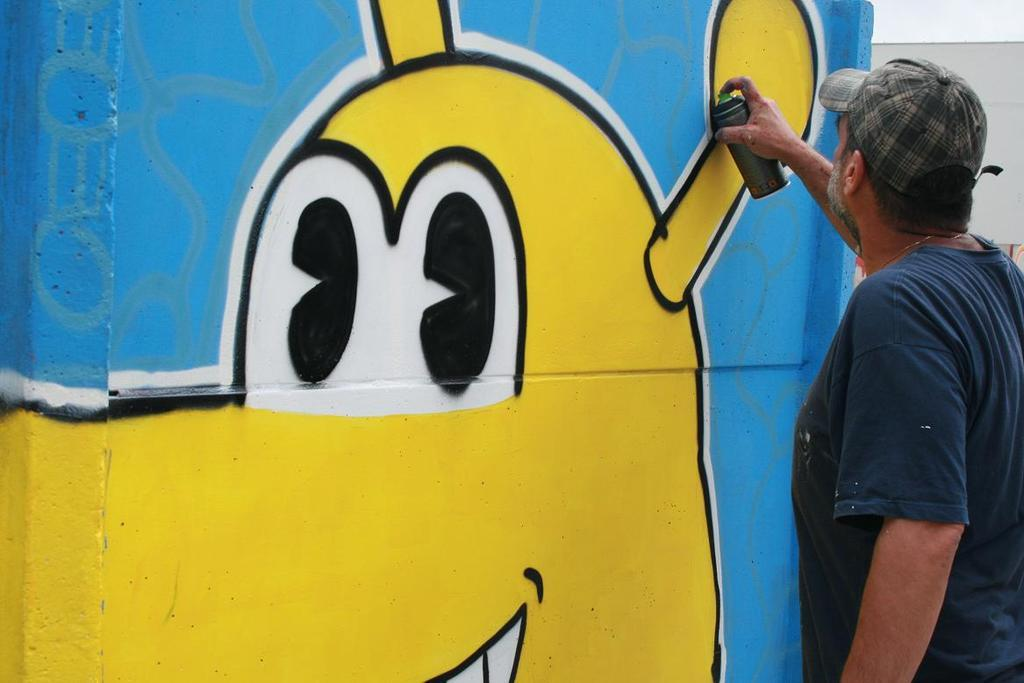What is the main subject of the image? There is a person in the image. What is the person wearing on their head? The person is wearing a cap. What is the person's posture in the image? The person is standing. What object is the person holding in the image? The person is holding a spray bottle. What can be seen on the wall in the image? There is a wall with graffiti in the image. How many horses are depicted in the graffiti on the wall? There is no mention of horses in the image, as it features a person holding a spray bottle and a wall with graffiti. 